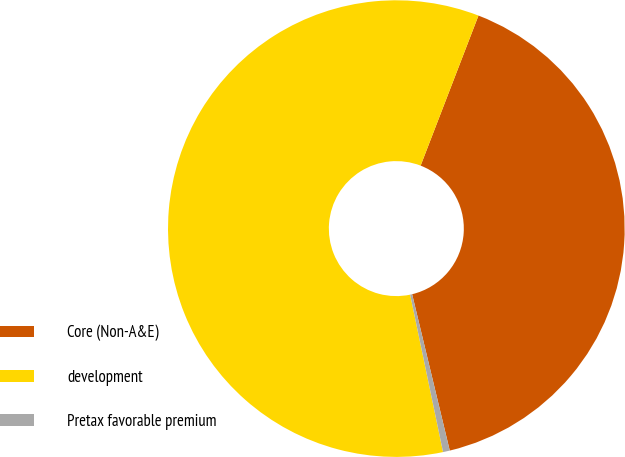<chart> <loc_0><loc_0><loc_500><loc_500><pie_chart><fcel>Core (Non-A&E)<fcel>development<fcel>Pretax favorable premium<nl><fcel>40.38%<fcel>59.13%<fcel>0.48%<nl></chart> 